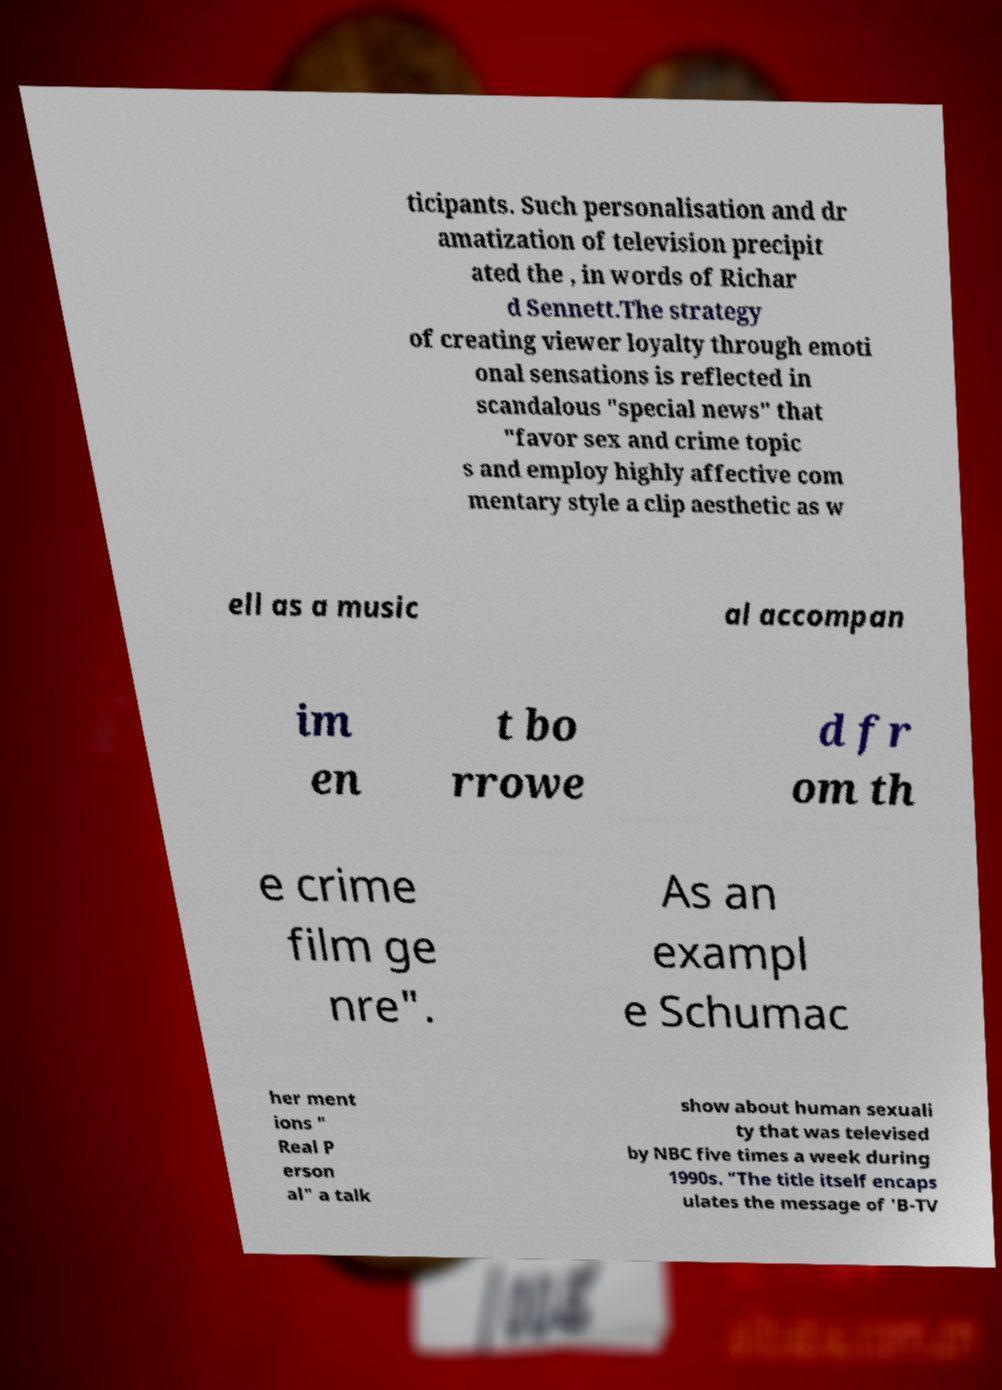Could you extract and type out the text from this image? ticipants. Such personalisation and dr amatization of television precipit ated the , in words of Richar d Sennett.The strategy of creating viewer loyalty through emoti onal sensations is reflected in scandalous "special news" that "favor sex and crime topic s and employ highly affective com mentary style a clip aesthetic as w ell as a music al accompan im en t bo rrowe d fr om th e crime film ge nre". As an exampl e Schumac her ment ions " Real P erson al" a talk show about human sexuali ty that was televised by NBC five times a week during 1990s. "The title itself encaps ulates the message of 'B-TV 